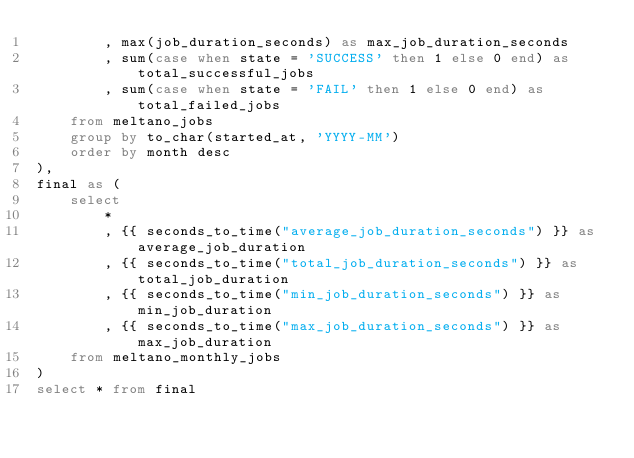<code> <loc_0><loc_0><loc_500><loc_500><_SQL_>        , max(job_duration_seconds) as max_job_duration_seconds
        , sum(case when state = 'SUCCESS' then 1 else 0 end) as total_successful_jobs
        , sum(case when state = 'FAIL' then 1 else 0 end) as total_failed_jobs
    from meltano_jobs
    group by to_char(started_at, 'YYYY-MM')
    order by month desc
),
final as (
    select
        *
        , {{ seconds_to_time("average_job_duration_seconds") }} as average_job_duration
        , {{ seconds_to_time("total_job_duration_seconds") }} as total_job_duration
        , {{ seconds_to_time("min_job_duration_seconds") }} as min_job_duration
        , {{ seconds_to_time("max_job_duration_seconds") }} as max_job_duration
    from meltano_monthly_jobs
)
select * from final</code> 